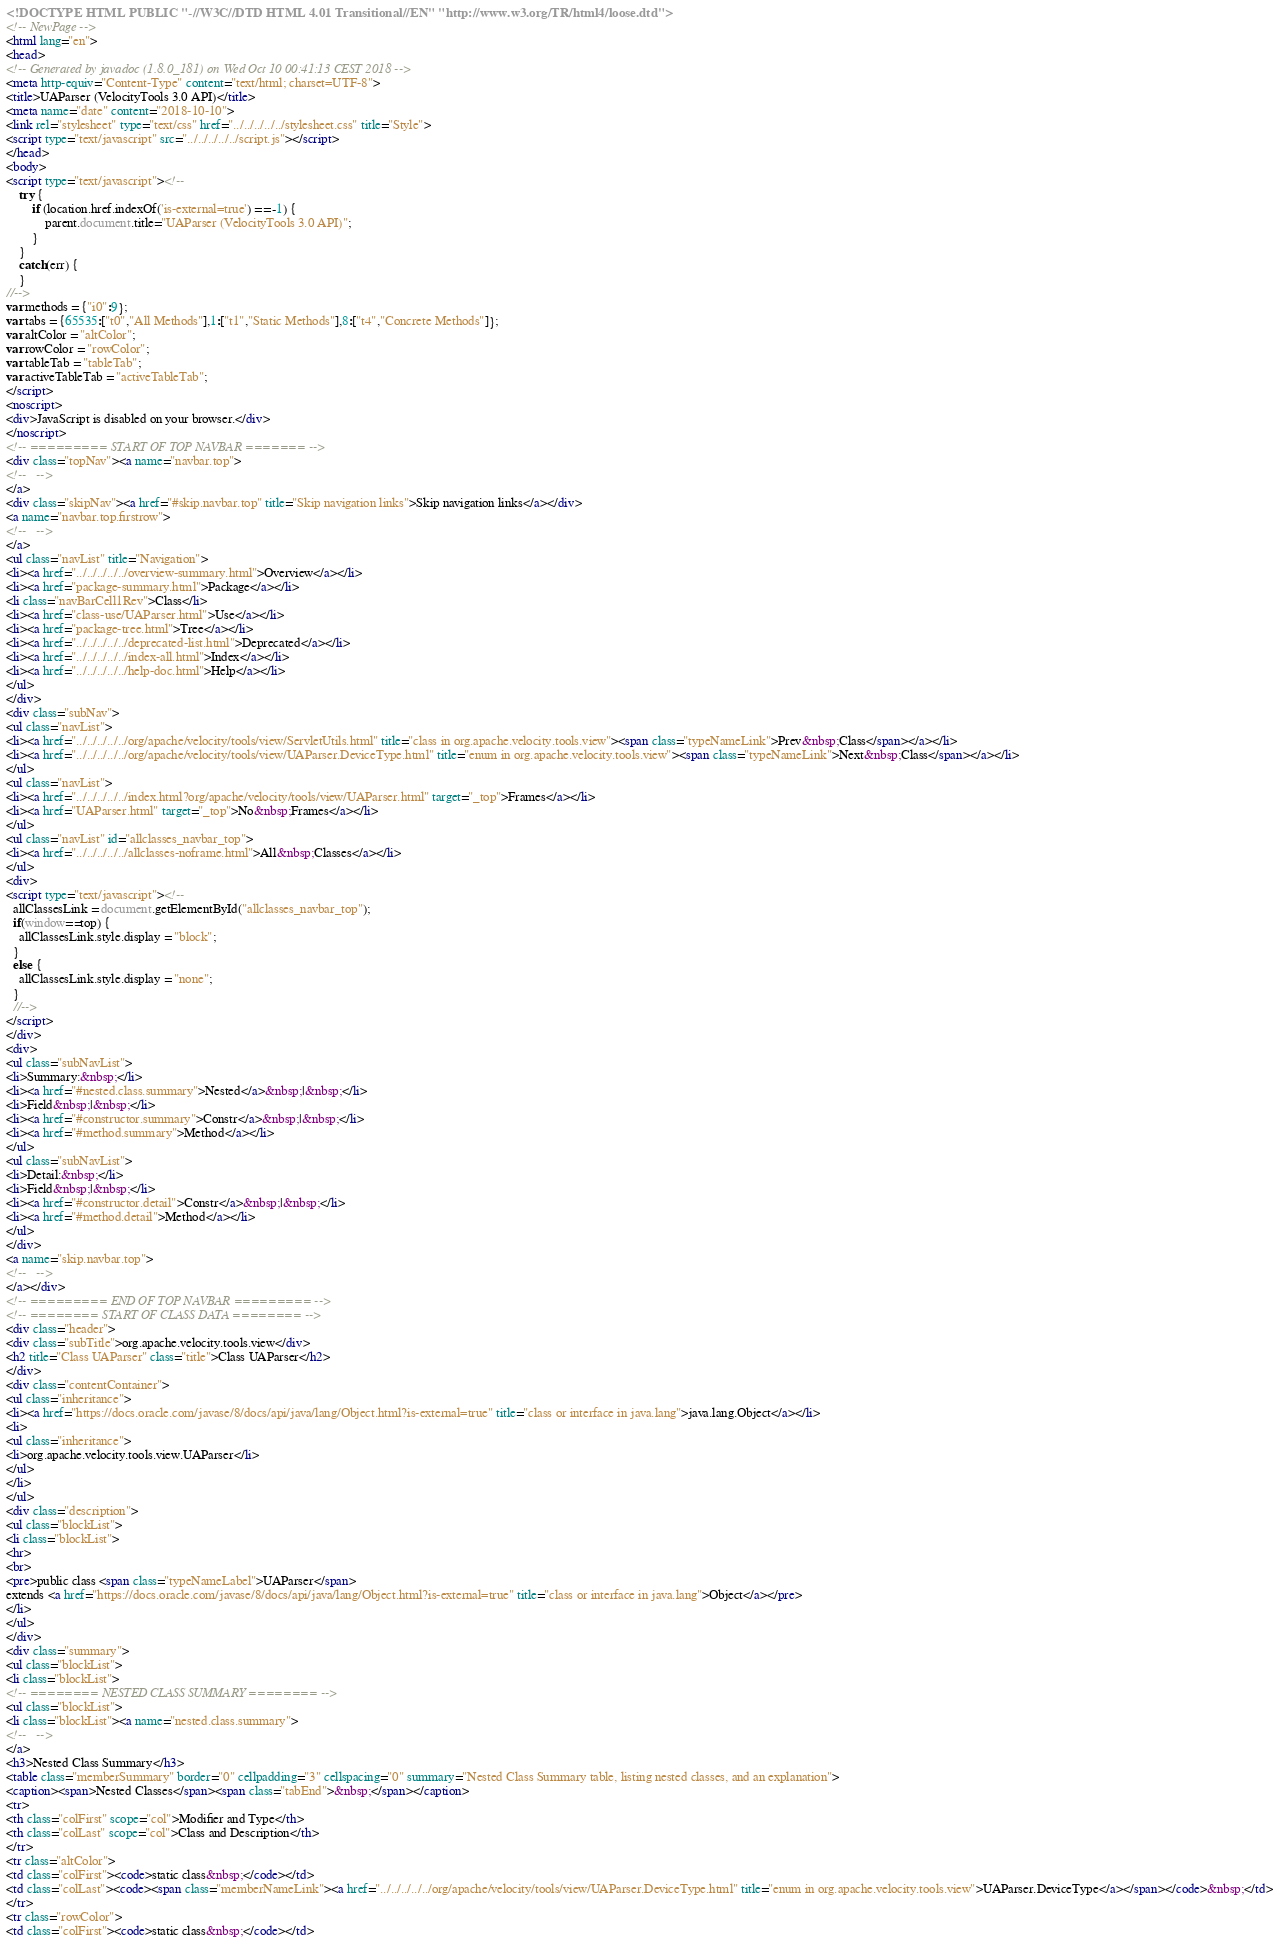<code> <loc_0><loc_0><loc_500><loc_500><_HTML_><!DOCTYPE HTML PUBLIC "-//W3C//DTD HTML 4.01 Transitional//EN" "http://www.w3.org/TR/html4/loose.dtd">
<!-- NewPage -->
<html lang="en">
<head>
<!-- Generated by javadoc (1.8.0_181) on Wed Oct 10 00:41:13 CEST 2018 -->
<meta http-equiv="Content-Type" content="text/html; charset=UTF-8">
<title>UAParser (VelocityTools 3.0 API)</title>
<meta name="date" content="2018-10-10">
<link rel="stylesheet" type="text/css" href="../../../../../stylesheet.css" title="Style">
<script type="text/javascript" src="../../../../../script.js"></script>
</head>
<body>
<script type="text/javascript"><!--
    try {
        if (location.href.indexOf('is-external=true') == -1) {
            parent.document.title="UAParser (VelocityTools 3.0 API)";
        }
    }
    catch(err) {
    }
//-->
var methods = {"i0":9};
var tabs = {65535:["t0","All Methods"],1:["t1","Static Methods"],8:["t4","Concrete Methods"]};
var altColor = "altColor";
var rowColor = "rowColor";
var tableTab = "tableTab";
var activeTableTab = "activeTableTab";
</script>
<noscript>
<div>JavaScript is disabled on your browser.</div>
</noscript>
<!-- ========= START OF TOP NAVBAR ======= -->
<div class="topNav"><a name="navbar.top">
<!--   -->
</a>
<div class="skipNav"><a href="#skip.navbar.top" title="Skip navigation links">Skip navigation links</a></div>
<a name="navbar.top.firstrow">
<!--   -->
</a>
<ul class="navList" title="Navigation">
<li><a href="../../../../../overview-summary.html">Overview</a></li>
<li><a href="package-summary.html">Package</a></li>
<li class="navBarCell1Rev">Class</li>
<li><a href="class-use/UAParser.html">Use</a></li>
<li><a href="package-tree.html">Tree</a></li>
<li><a href="../../../../../deprecated-list.html">Deprecated</a></li>
<li><a href="../../../../../index-all.html">Index</a></li>
<li><a href="../../../../../help-doc.html">Help</a></li>
</ul>
</div>
<div class="subNav">
<ul class="navList">
<li><a href="../../../../../org/apache/velocity/tools/view/ServletUtils.html" title="class in org.apache.velocity.tools.view"><span class="typeNameLink">Prev&nbsp;Class</span></a></li>
<li><a href="../../../../../org/apache/velocity/tools/view/UAParser.DeviceType.html" title="enum in org.apache.velocity.tools.view"><span class="typeNameLink">Next&nbsp;Class</span></a></li>
</ul>
<ul class="navList">
<li><a href="../../../../../index.html?org/apache/velocity/tools/view/UAParser.html" target="_top">Frames</a></li>
<li><a href="UAParser.html" target="_top">No&nbsp;Frames</a></li>
</ul>
<ul class="navList" id="allclasses_navbar_top">
<li><a href="../../../../../allclasses-noframe.html">All&nbsp;Classes</a></li>
</ul>
<div>
<script type="text/javascript"><!--
  allClassesLink = document.getElementById("allclasses_navbar_top");
  if(window==top) {
    allClassesLink.style.display = "block";
  }
  else {
    allClassesLink.style.display = "none";
  }
  //-->
</script>
</div>
<div>
<ul class="subNavList">
<li>Summary:&nbsp;</li>
<li><a href="#nested.class.summary">Nested</a>&nbsp;|&nbsp;</li>
<li>Field&nbsp;|&nbsp;</li>
<li><a href="#constructor.summary">Constr</a>&nbsp;|&nbsp;</li>
<li><a href="#method.summary">Method</a></li>
</ul>
<ul class="subNavList">
<li>Detail:&nbsp;</li>
<li>Field&nbsp;|&nbsp;</li>
<li><a href="#constructor.detail">Constr</a>&nbsp;|&nbsp;</li>
<li><a href="#method.detail">Method</a></li>
</ul>
</div>
<a name="skip.navbar.top">
<!--   -->
</a></div>
<!-- ========= END OF TOP NAVBAR ========= -->
<!-- ======== START OF CLASS DATA ======== -->
<div class="header">
<div class="subTitle">org.apache.velocity.tools.view</div>
<h2 title="Class UAParser" class="title">Class UAParser</h2>
</div>
<div class="contentContainer">
<ul class="inheritance">
<li><a href="https://docs.oracle.com/javase/8/docs/api/java/lang/Object.html?is-external=true" title="class or interface in java.lang">java.lang.Object</a></li>
<li>
<ul class="inheritance">
<li>org.apache.velocity.tools.view.UAParser</li>
</ul>
</li>
</ul>
<div class="description">
<ul class="blockList">
<li class="blockList">
<hr>
<br>
<pre>public class <span class="typeNameLabel">UAParser</span>
extends <a href="https://docs.oracle.com/javase/8/docs/api/java/lang/Object.html?is-external=true" title="class or interface in java.lang">Object</a></pre>
</li>
</ul>
</div>
<div class="summary">
<ul class="blockList">
<li class="blockList">
<!-- ======== NESTED CLASS SUMMARY ======== -->
<ul class="blockList">
<li class="blockList"><a name="nested.class.summary">
<!--   -->
</a>
<h3>Nested Class Summary</h3>
<table class="memberSummary" border="0" cellpadding="3" cellspacing="0" summary="Nested Class Summary table, listing nested classes, and an explanation">
<caption><span>Nested Classes</span><span class="tabEnd">&nbsp;</span></caption>
<tr>
<th class="colFirst" scope="col">Modifier and Type</th>
<th class="colLast" scope="col">Class and Description</th>
</tr>
<tr class="altColor">
<td class="colFirst"><code>static class&nbsp;</code></td>
<td class="colLast"><code><span class="memberNameLink"><a href="../../../../../org/apache/velocity/tools/view/UAParser.DeviceType.html" title="enum in org.apache.velocity.tools.view">UAParser.DeviceType</a></span></code>&nbsp;</td>
</tr>
<tr class="rowColor">
<td class="colFirst"><code>static class&nbsp;</code></td></code> 